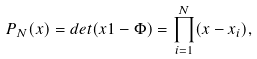Convert formula to latex. <formula><loc_0><loc_0><loc_500><loc_500>P _ { N } ( x ) = d e t ( x 1 - \Phi ) = \prod _ { i = 1 } ^ { N } ( x - x _ { i } ) ,</formula> 